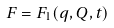Convert formula to latex. <formula><loc_0><loc_0><loc_500><loc_500>F = F _ { 1 } ( q , Q , t )</formula> 